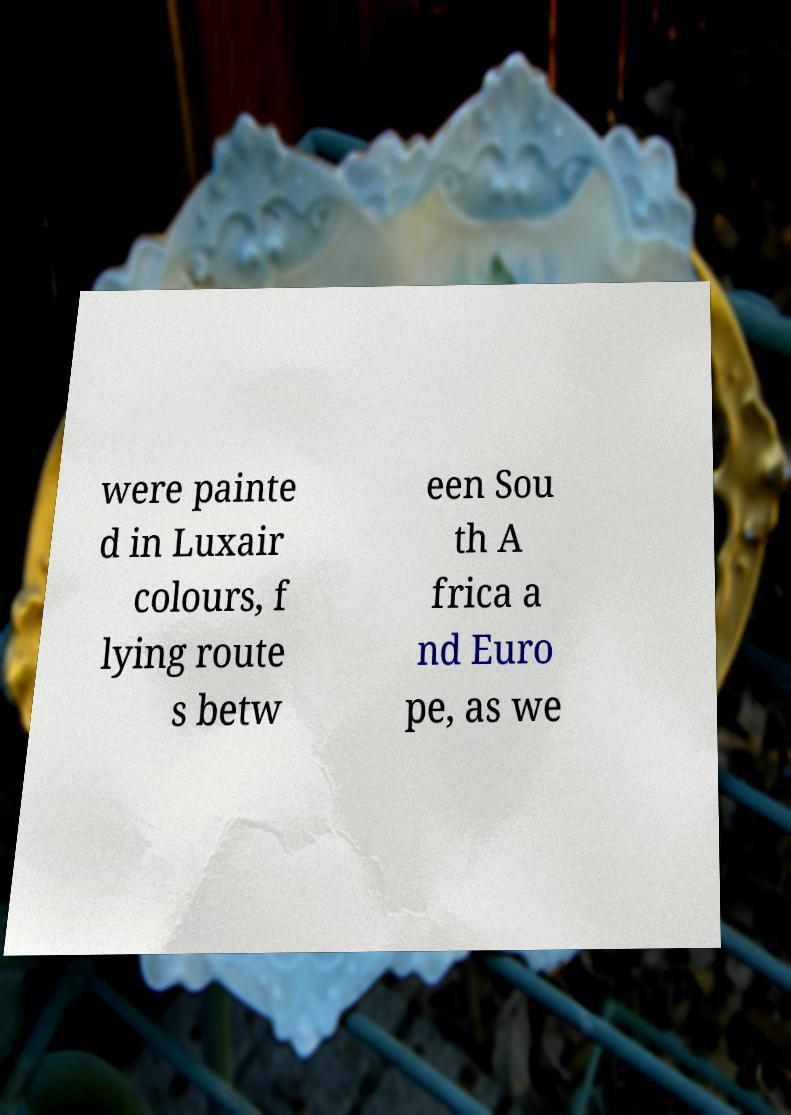I need the written content from this picture converted into text. Can you do that? were painte d in Luxair colours, f lying route s betw een Sou th A frica a nd Euro pe, as we 